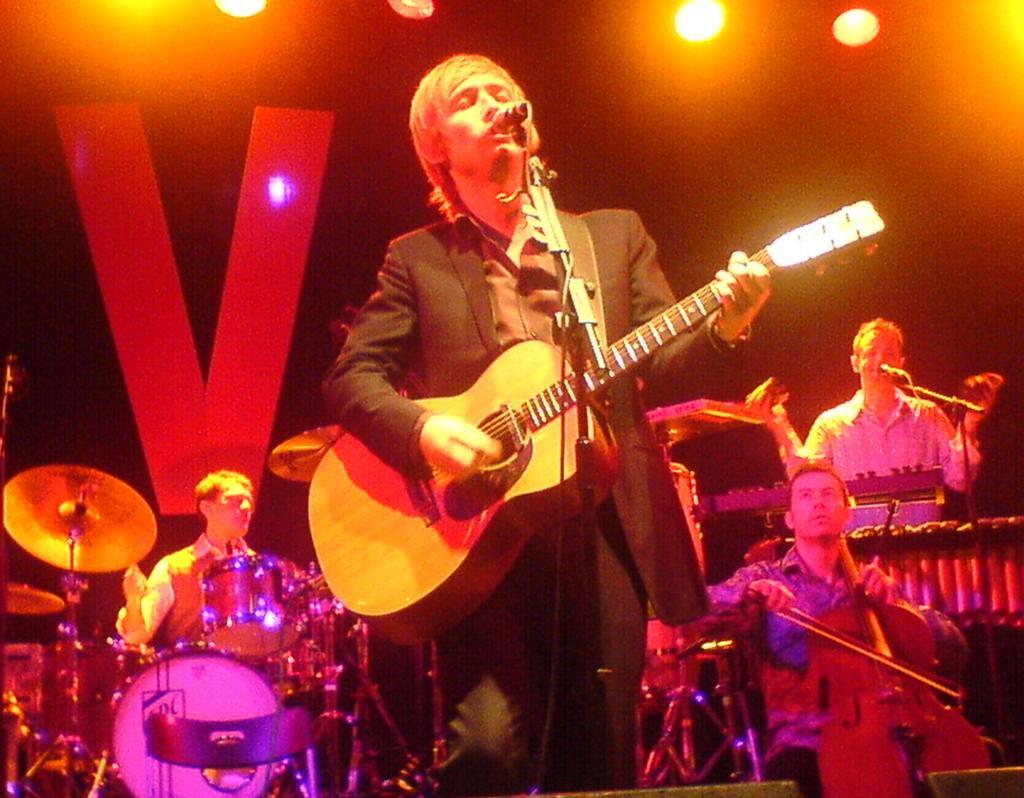Could you give a brief overview of what you see in this image? In the picture there are few musicians and singers. The man to the left corner is playing drums. The man to the right corner is singing and in front of him there is microphone. The man beside him is playing cello. The man in the center is playing guitar as well as singing. In the background there is wall and V written on it. At top of the image there are spot lights. 